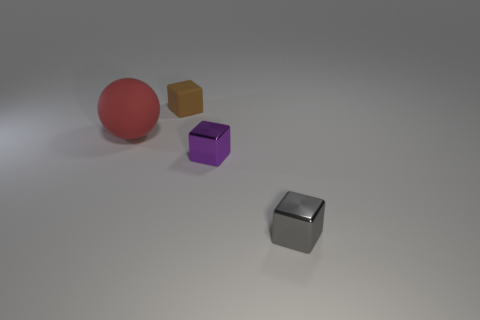The object that is the same material as the tiny brown block is what color?
Provide a succinct answer. Red. How many large things are made of the same material as the tiny gray block?
Your answer should be compact. 0. What color is the tiny thing behind the matte object in front of the thing that is behind the ball?
Keep it short and to the point. Brown. Is the size of the sphere the same as the purple metal block?
Offer a terse response. No. Are there any other things that are the same shape as the large thing?
Your response must be concise. No. What number of things are cubes that are right of the brown object or blue metal cylinders?
Provide a short and direct response. 2. Is the small purple object the same shape as the red object?
Offer a very short reply. No. How many other objects are there of the same size as the brown thing?
Your response must be concise. 2. What color is the large ball?
Your response must be concise. Red. How many small things are either rubber spheres or purple shiny objects?
Give a very brief answer. 1. 